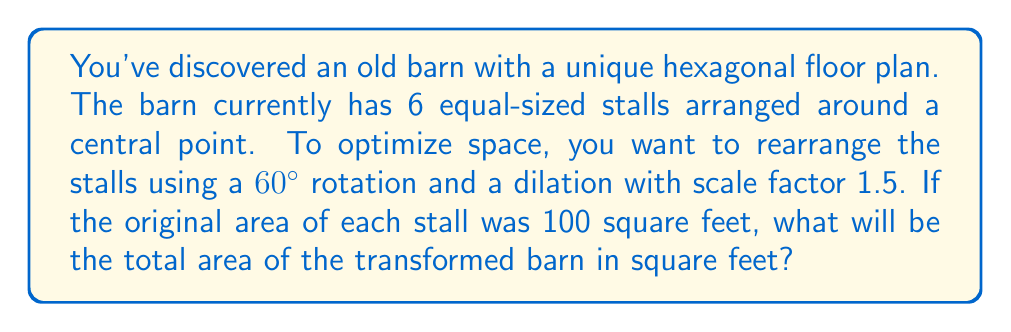Can you answer this question? Let's approach this step-by-step:

1) First, we need to understand what the transformations do:
   - A 60° rotation doesn't change the size or shape of the stalls.
   - A dilation with scale factor 1.5 enlarges each stall.

2) The dilation is the key transformation that affects the area. In a dilation:
   $$(new\,area) = (scale\,factor)^2 \times (original\,area)$$

3) Let's calculate the new area of each stall:
   $$new\,area = 1.5^2 \times 100 = 2.25 \times 100 = 225\,sq\,ft$$

4) Now, we need to find the total area of all 6 stalls:
   $$total\,area = 6 \times 225 = 1350\,sq\,ft$$

5) To visualize this transformation, we can represent it as follows:

[asy]
unitsize(1cm);
for(int i=0; i<6; ++i) {
  fill(rotate(60*i)*scale(1.5)*polygon(6), lightgray);
  draw(rotate(60*i)*scale(1.5)*polygon(6));
}
draw(circle(origin,1.5), dashed);
label("Original", (0,1.7));
label("Transformed", (0,-1.7));
[/asy]

The dashed circle represents the original barn, while the solid hexagon shows the transformed barn.
Answer: 1350 sq ft 